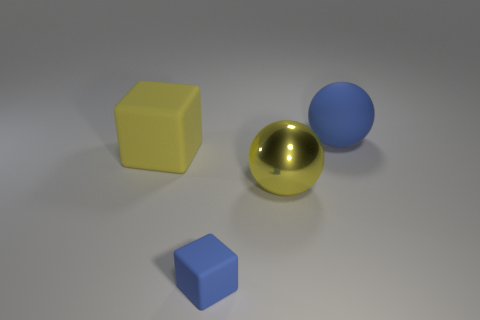Add 2 yellow metallic things. How many objects exist? 6 Subtract all blue blocks. How many blocks are left? 1 Subtract all brown cubes. Subtract all cyan cylinders. How many cubes are left? 2 Subtract all big yellow rubber things. Subtract all matte blocks. How many objects are left? 1 Add 3 metal objects. How many metal objects are left? 4 Add 1 yellow metal spheres. How many yellow metal spheres exist? 2 Subtract 0 cyan cylinders. How many objects are left? 4 